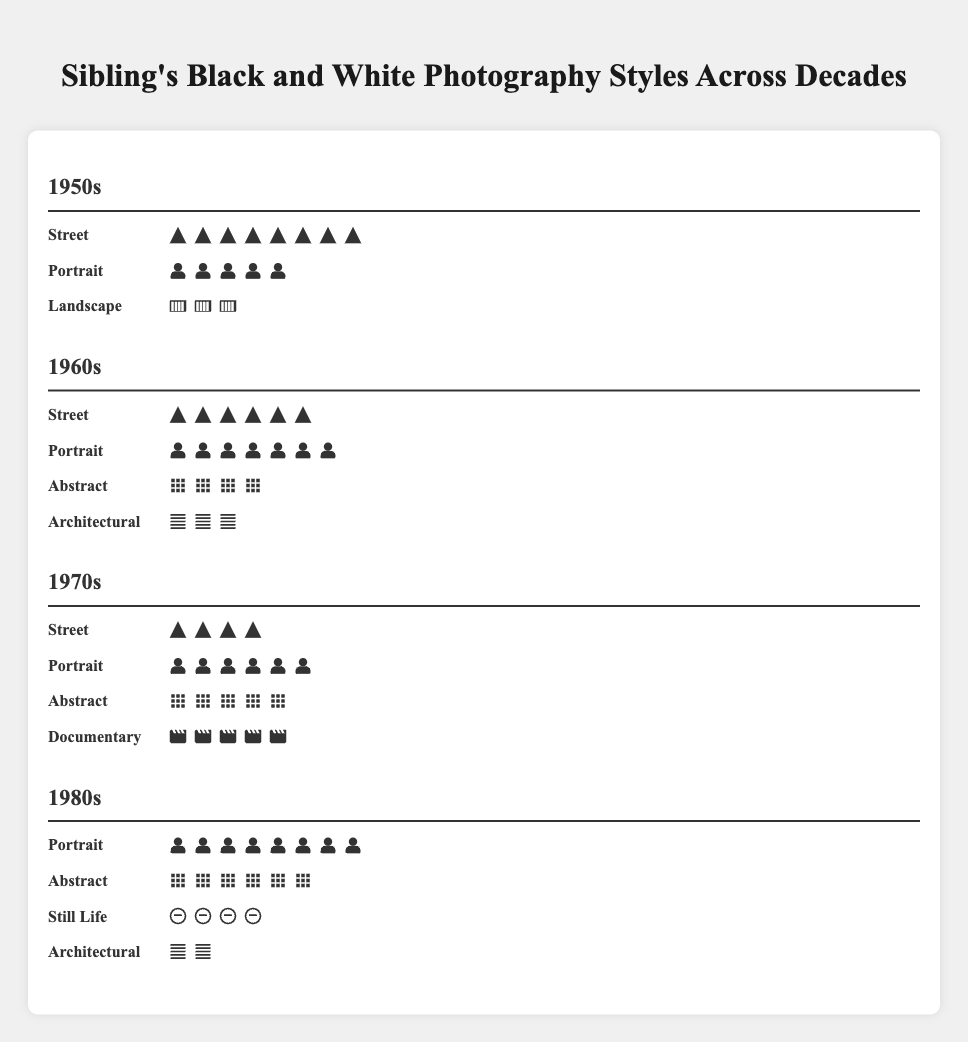How many street photographs were taken in the 1950s? The figure shows 8 icons representing street photographs under the 1950s section.
Answer: 8 Which style had the highest count in the 1970s? The figure for the 1970s shows 6 icons for Portrait, the highest among the styles listed.
Answer: Portrait Compare the number of Architectural photographs between the 1960s and the 1980s. Which decade had more? The 1960s had 3 icons for Architectural, while the 1980s had 2 icons. Therefore, the 1960s had more Architectural photographs.
Answer: 1960s What is the total number of Abstract photographs taken across all decades? Add the number of Abstract photographs from each decade: 1960s (4), 1970s (5), and 1980s (6), resulting in 4 + 5 + 6 = 15.
Answer: 15 Which decade had the least number of Landscape photographs? The data shows Landscape photographs only for the 1950s, with 3 icons. Other decades have none, so they all have less than 3.
Answer: 1960s, 1970s, 1980s What is the change in the number of Street photographs from the 1950s to the 1980s? The number of Street photographs decreased from 8 in the 1950s to 0 in the 1980s, resulting in a change of 8 - 0 = 8.
Answer: 8 Find the average number of styles represented in each decade. Count the distinct styles in each decade: 3 in the 1950s, 4 in the 1960s, 4 in the 1970s, and 4 in the 1980s. For average: (3+4+4+4)/4 = 3.75
Answer: 3.75 Which style appeared in every decade? By observing the figure, Portrait appears in all sections (1950s, 1960s, 1970s, 1980s).
Answer: Portrait How many total photographs were taken in the 1980s? Add the counts of all styles in the 1980s: Portrait (8), Abstract (6), Still Life (4), Architectural (2) resulting in 8 + 6 + 4 + 2 = 20.
Answer: 20 What is the most common photography style overall in the figure? By summing up the counts of each style across all decades, the one with the highest sum is Portrait.
Answer: Portrait 